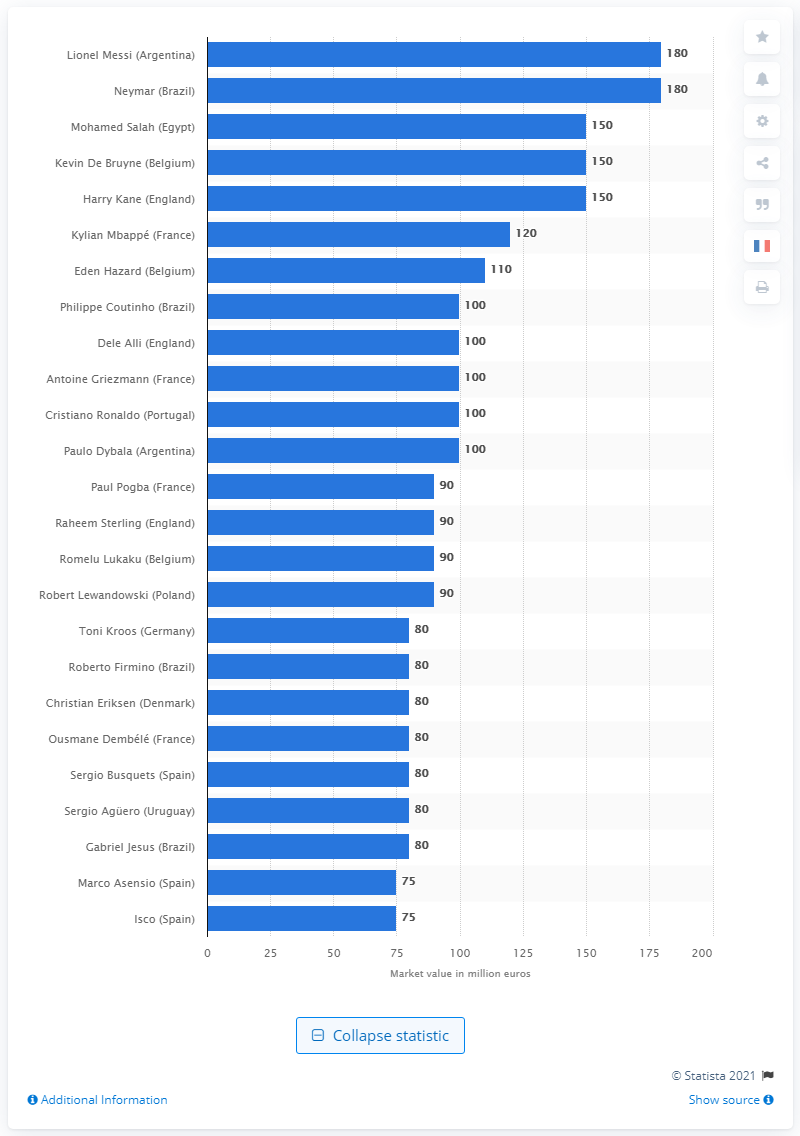Mention a couple of crucial points in this snapshot. Lionel Messi's transfer market value is 180.. 